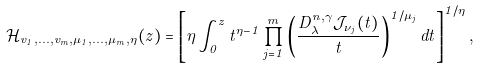Convert formula to latex. <formula><loc_0><loc_0><loc_500><loc_500>\mathcal { H } _ { v _ { 1 } , \dots , v _ { m } , \mu _ { 1 } , \dots , \mu _ { m } , \eta } ( z ) = \left [ \eta \int _ { 0 } ^ { z } t ^ { \eta - 1 } \prod _ { j = 1 } ^ { m } \left ( \frac { D _ { \lambda } ^ { n , \gamma } \mathcal { J } _ { \nu _ { j } } ( t ) } { t } \right ) ^ { 1 / \mu _ { j } } d t \right ] ^ { 1 / \eta } ,</formula> 